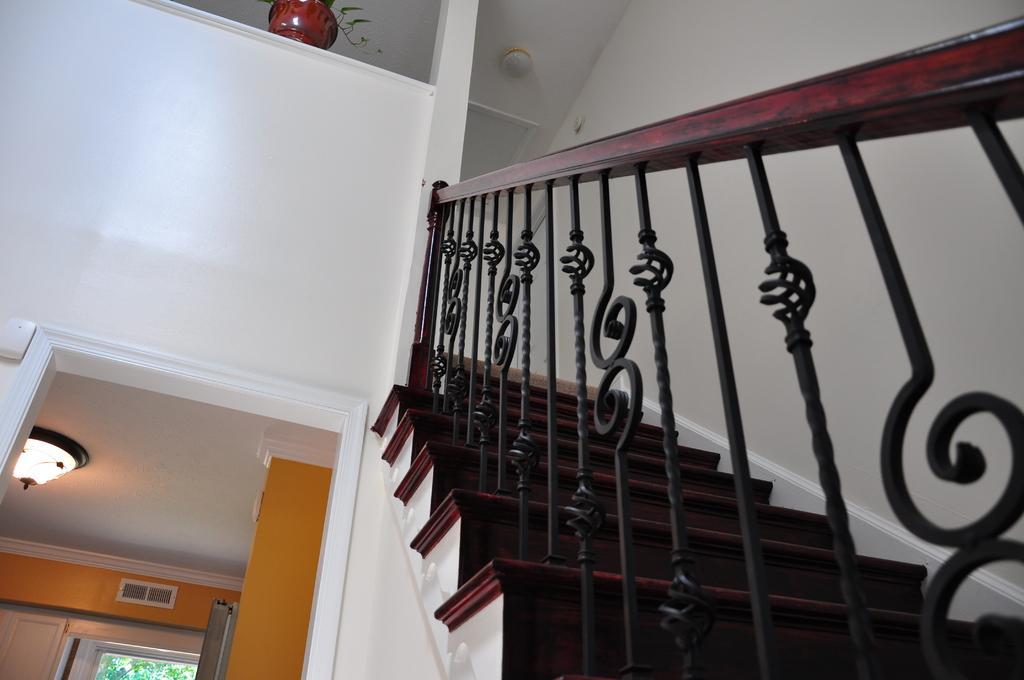How would you summarize this image in a sentence or two? In this image I can see the railing and stairs. In the top I can see the flower pot. I can see the light, wall and trees in the image. 